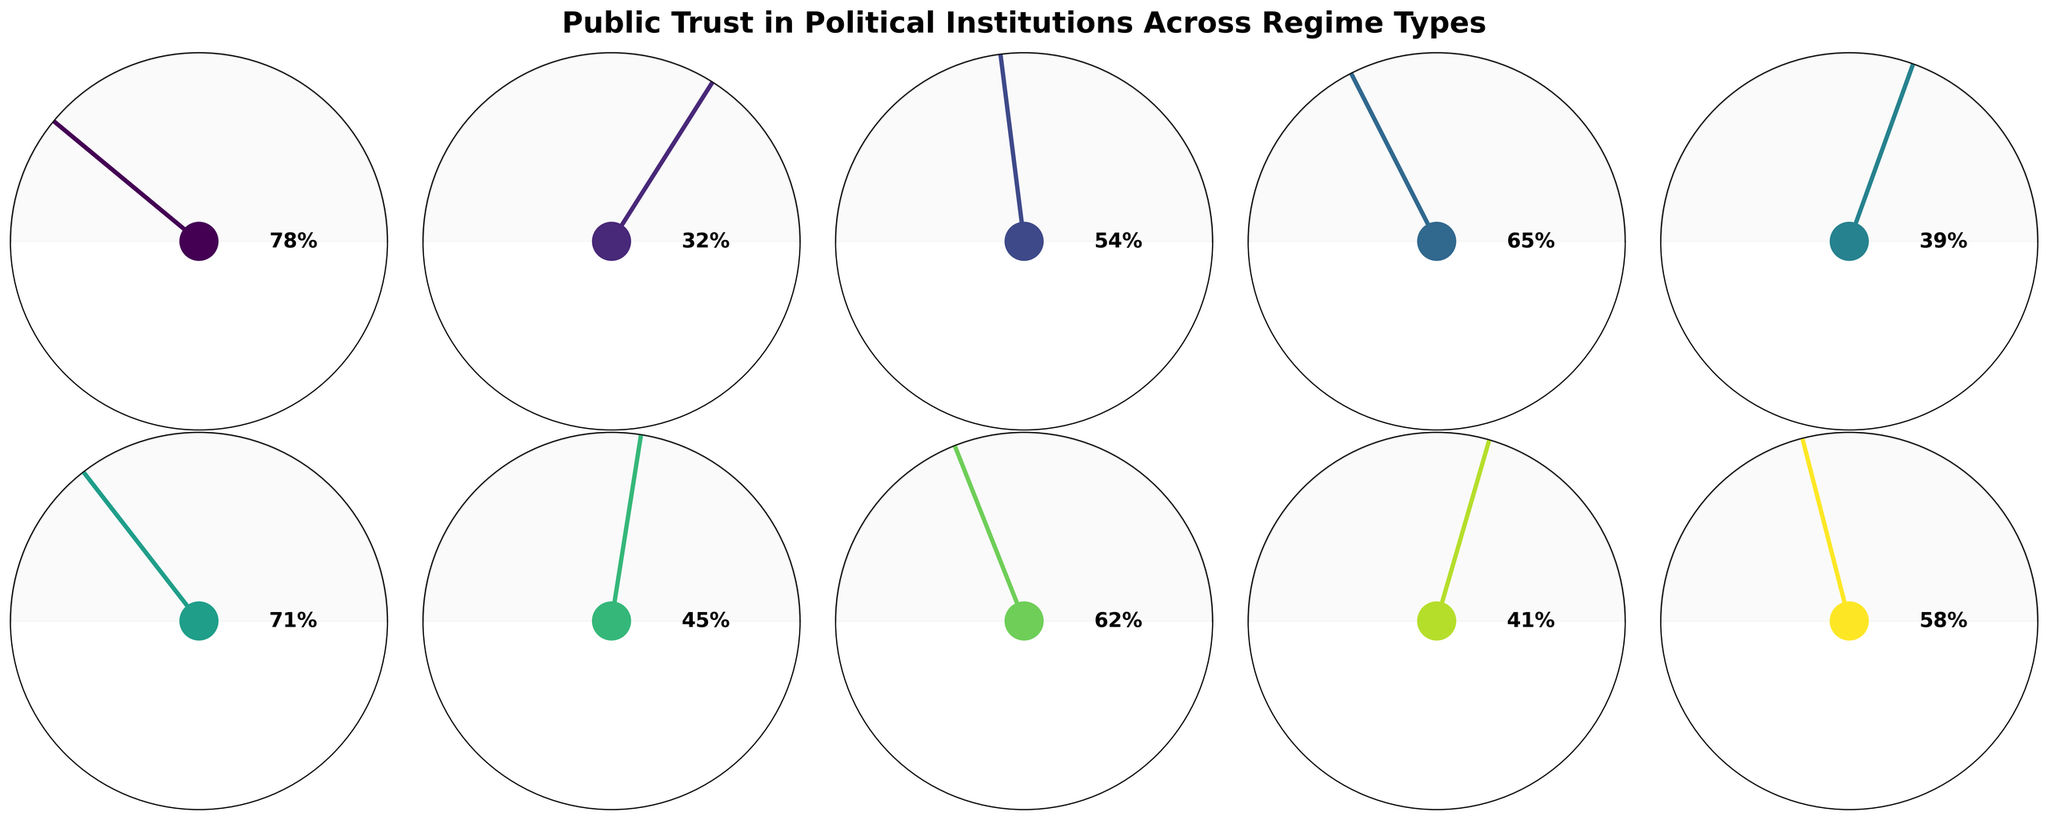What is the title of the figure? The title of the figure is written at the top of the chart. By looking at the figure, you can identify the title.
Answer: Public Trust in Political Institutions Across Regime Types Which country has the highest trust score in political institutions? To find the country with the highest trust score, look for the gauge that points furthest to the right (towards a higher degree value). In this case, it's Sweden.
Answer: Sweden What is the trust score for Turkey? Locate the gauge chart for Turkey and read the percentage value indicated on the figure.
Answer: 41% How many countries have a trust score above 50%? Check each gauge chart and count the number of countries that have a trust score greater than 50%. These are Sweden, the United States, China, Germany, Japan, and India.
Answer: 6 Which regime type shows the highest trust score? Find the country with the highest trust score (Sweden) and note its regime type from the figure.
Answer: Liberal Democracy What is the average trust score of countries with Presidential Democracies? The countries with Presidential Democracies are the United States and Brazil. The trust scores are 54 and 39. Average = (54+39)/2 = 46.5
Answer: 46.5 Which country has the lowest trust score in political institutions? Identify the gauge that points the least (towards a lower degree value). In this case, it's Russia.
Answer: Russia Compare the trust score between Germany and Japan. Which country has a higher score? Look at the gauge charts for Germany and Japan and compare the values indicated. Germany's trust score is 71%, and Japan's is 62%.
Answer: Germany Among the different types of regimes, how many types have a representative in the figure? Count the distinct regime types indicated in the figure. They are Liberal Democracy, Authoritarian, Presidential Democracy, One-Party State, Theocracy, Parliamentary Democracy, Hybrid Regime, and Federal Parliamentary Democracy.
Answer: 8 What is the difference in the trust score between China and Iran? Locate the trust scores for China (65%) and Iran (45%) in the figure. Calculate the difference: 65 - 45 = 20.
Answer: 20 